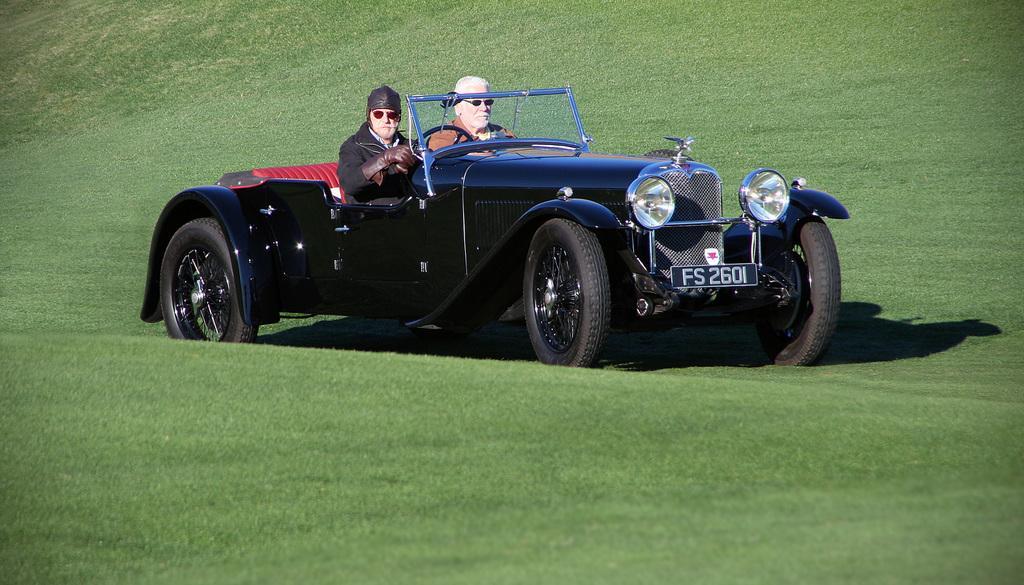Could you give a brief overview of what you see in this image? This man wore black jacket and riding this black vehicle on this grass. Beside this man another person is also sitting. 